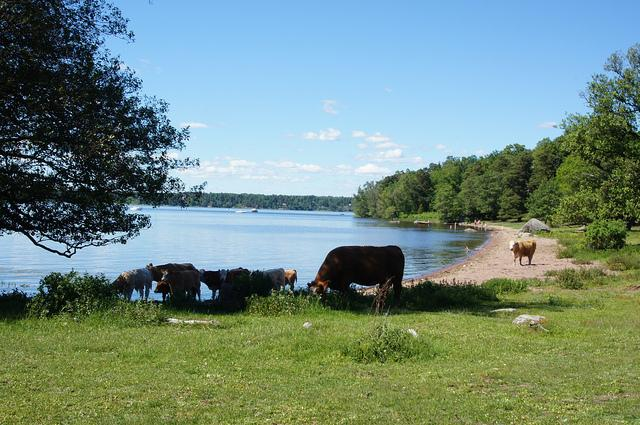How many animal species are shown NOT including the people on shore?

Choices:
A) one
B) nine
C) 11
D) five one 